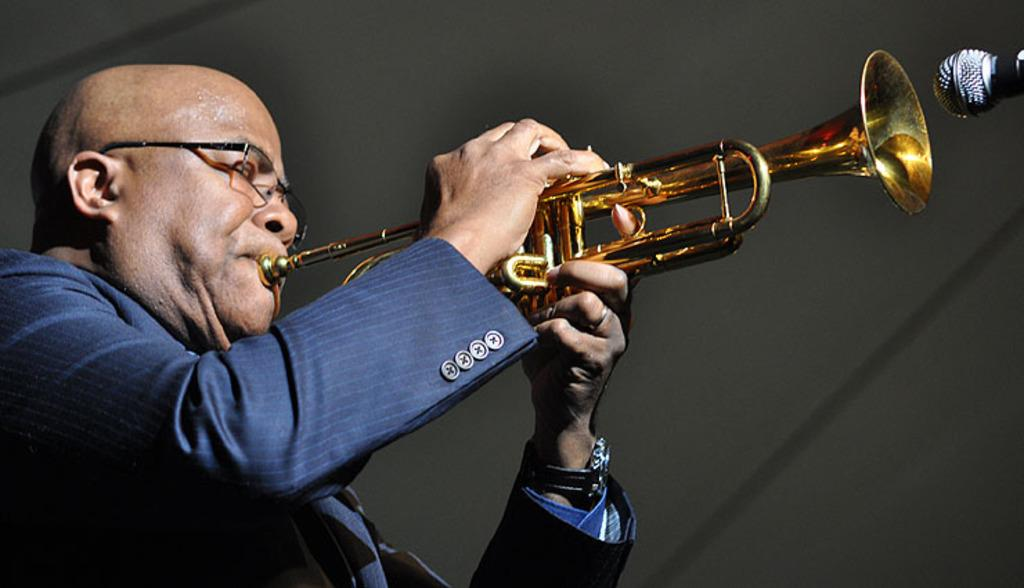What can be seen in the image? There is a person in the image. What is the person wearing? The person is wearing a blue jacket. What is the person holding? The person is holding a musical instrument. What object is on the right side of the image? There is a microphone on the right side of the image. How many ladybugs are crawling on the person's blue jacket in the image? There are no ladybugs present in the image; the person is wearing a blue jacket and holding a musical instrument. 